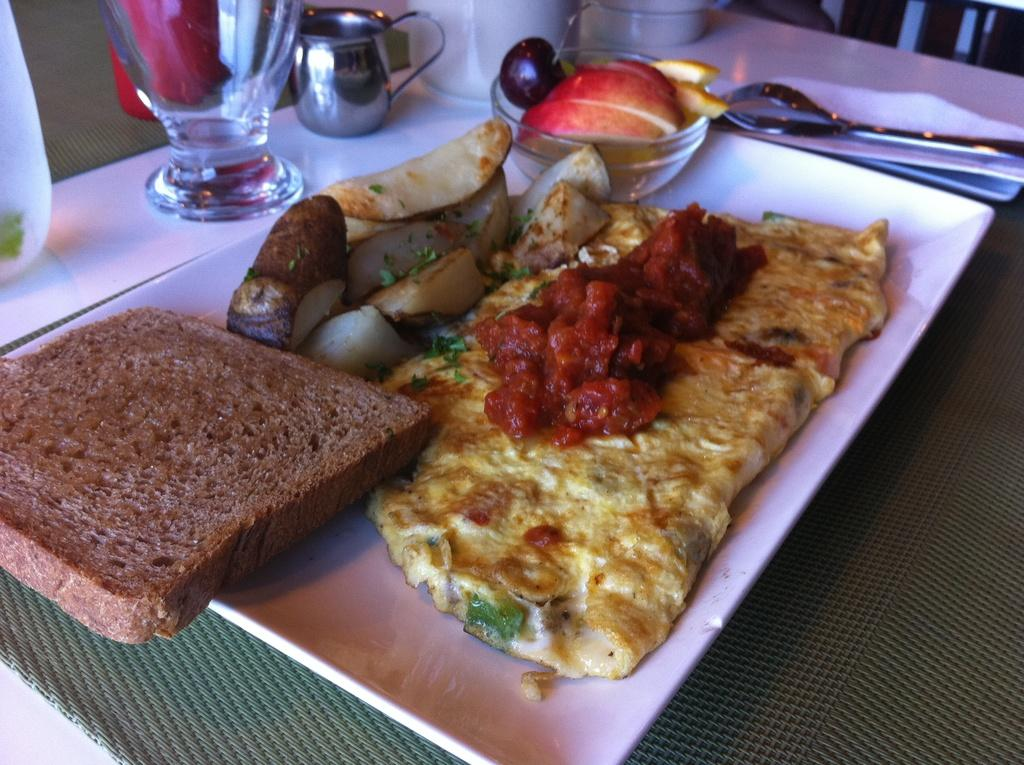What type of bread can be seen in the image? There is brown bread in the image. What other food items are present on the plate? There is an omelet, pickles, and fruits on the plate. What utensils are visible in the image? There is a spoon and a fork in the image. How is the plate placed in the image? The plate is on a tissue. What other items can be seen on the table? There is a glass, a cup, and a jug on the table. How many toes are visible in the image? There are no toes visible in the image; it features food items, utensils, and other tableware. Are there any cows present in the image? There are no cows present in the image; it features food items, utensils, and other tableware. 